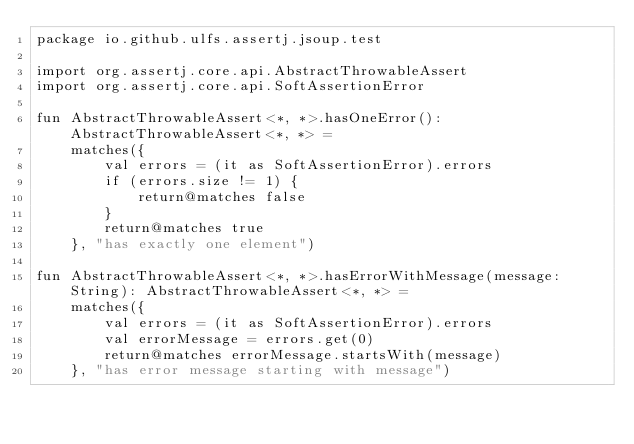Convert code to text. <code><loc_0><loc_0><loc_500><loc_500><_Kotlin_>package io.github.ulfs.assertj.jsoup.test

import org.assertj.core.api.AbstractThrowableAssert
import org.assertj.core.api.SoftAssertionError

fun AbstractThrowableAssert<*, *>.hasOneError(): AbstractThrowableAssert<*, *> =
    matches({
        val errors = (it as SoftAssertionError).errors
        if (errors.size != 1) {
            return@matches false
        }
        return@matches true
    }, "has exactly one element")

fun AbstractThrowableAssert<*, *>.hasErrorWithMessage(message: String): AbstractThrowableAssert<*, *> =
    matches({
        val errors = (it as SoftAssertionError).errors
        val errorMessage = errors.get(0)
        return@matches errorMessage.startsWith(message)
    }, "has error message starting with message")
</code> 